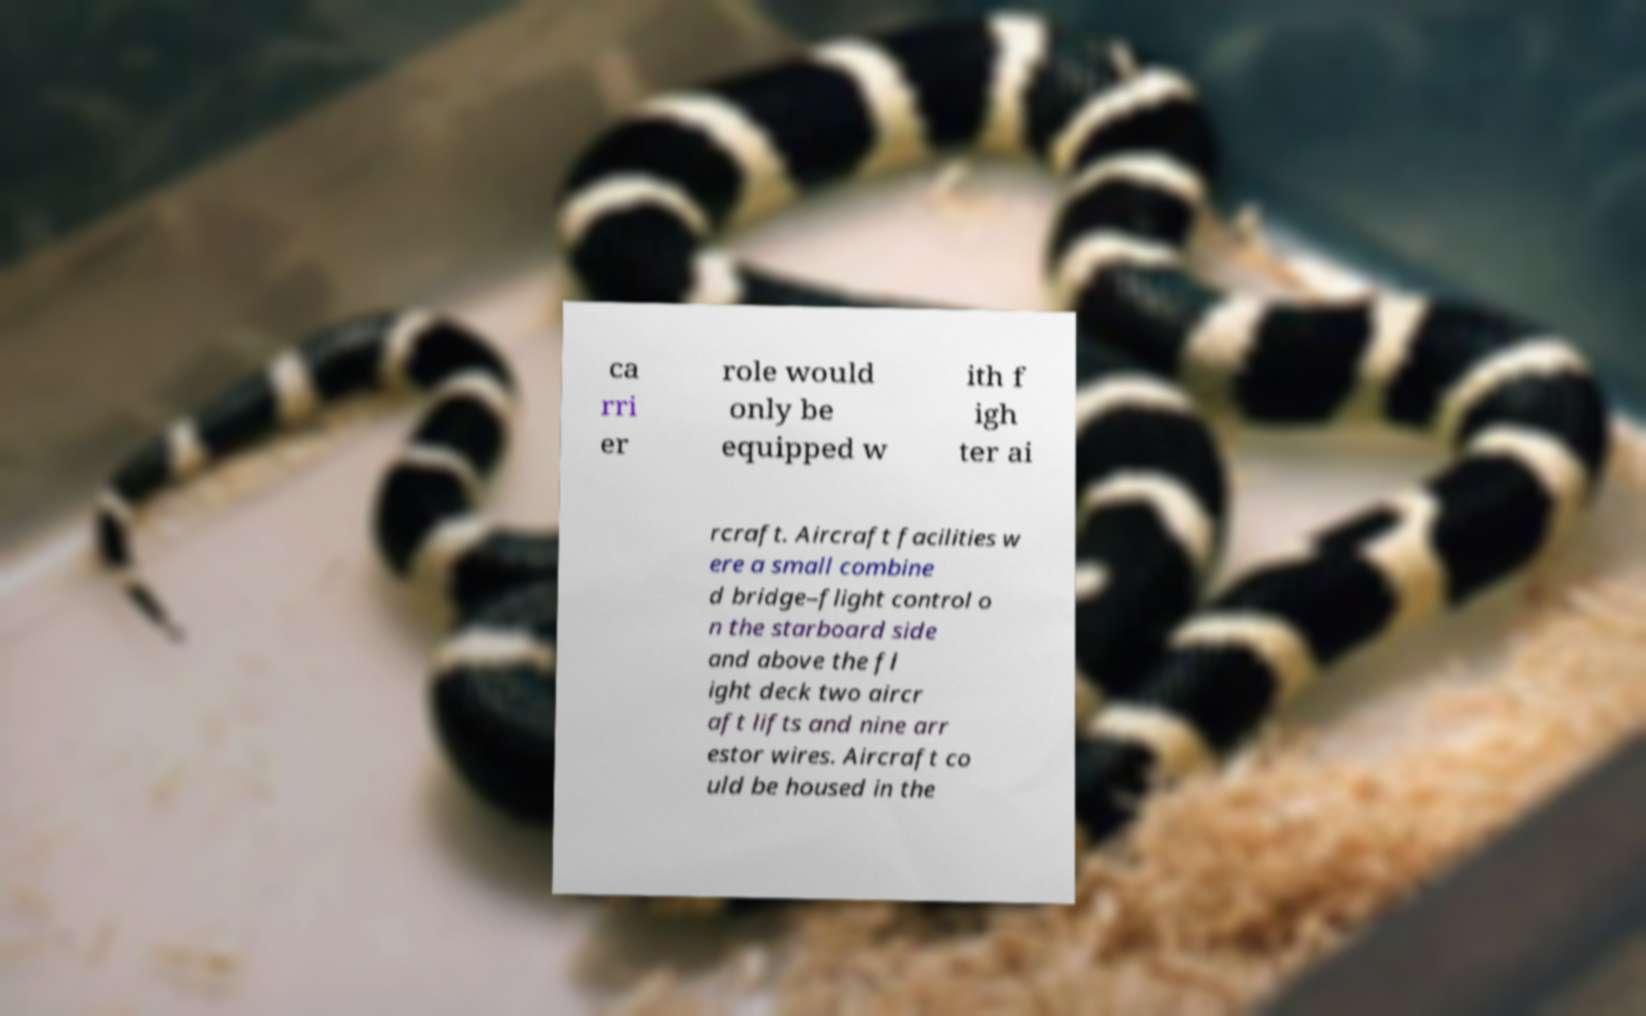Can you accurately transcribe the text from the provided image for me? ca rri er role would only be equipped w ith f igh ter ai rcraft. Aircraft facilities w ere a small combine d bridge–flight control o n the starboard side and above the fl ight deck two aircr aft lifts and nine arr estor wires. Aircraft co uld be housed in the 